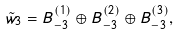<formula> <loc_0><loc_0><loc_500><loc_500>\tilde { w } _ { 3 } = B _ { - 3 } ^ { ( 1 ) } \oplus B _ { - 3 } ^ { ( 2 ) } \oplus B _ { - 3 } ^ { ( 3 ) } ,</formula> 